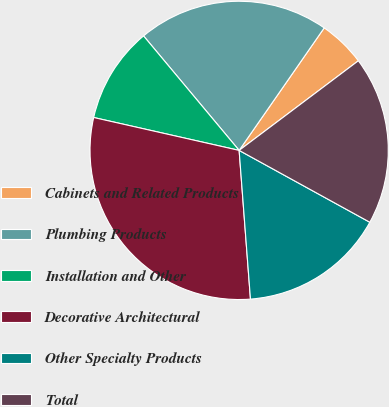Convert chart. <chart><loc_0><loc_0><loc_500><loc_500><pie_chart><fcel>Cabinets and Related Products<fcel>Plumbing Products<fcel>Installation and Other<fcel>Decorative Architectural<fcel>Other Specialty Products<fcel>Total<nl><fcel>5.08%<fcel>20.73%<fcel>10.39%<fcel>29.75%<fcel>15.79%<fcel>18.26%<nl></chart> 